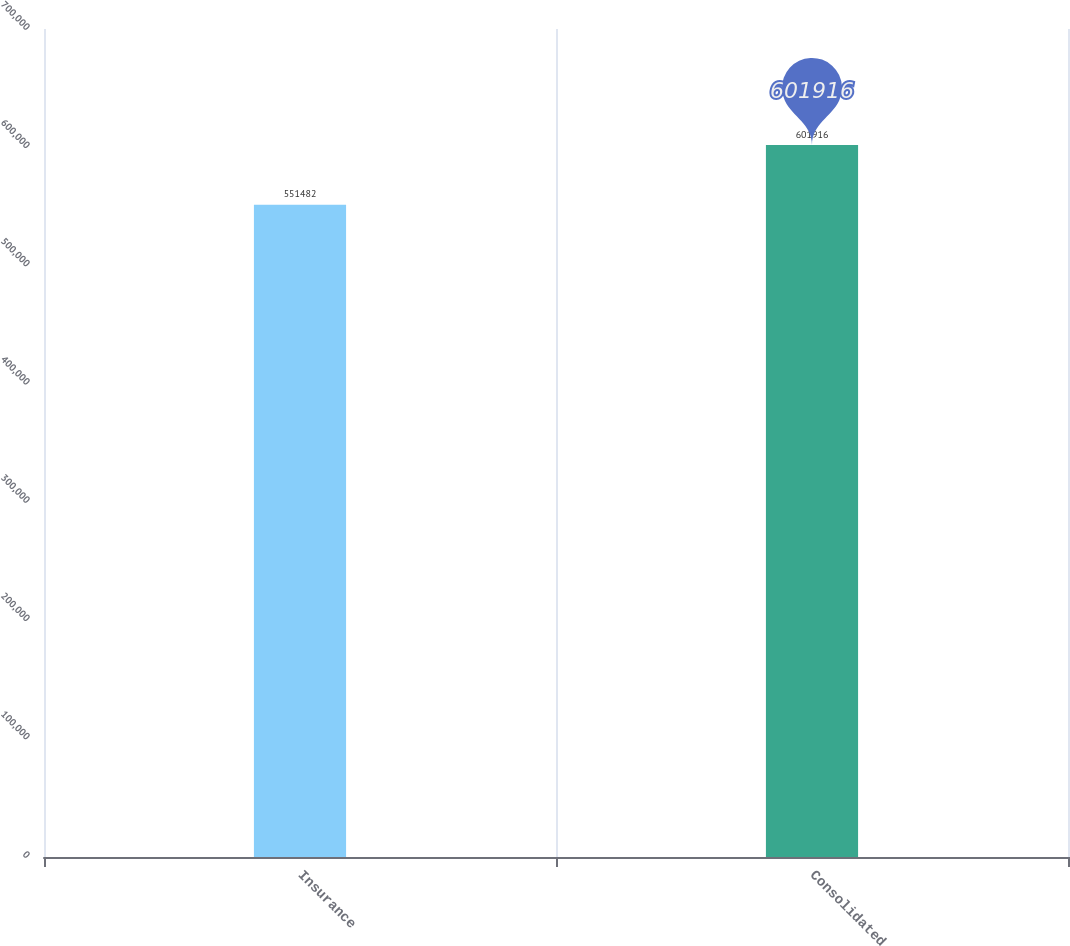Convert chart. <chart><loc_0><loc_0><loc_500><loc_500><bar_chart><fcel>Insurance<fcel>Consolidated<nl><fcel>551482<fcel>601916<nl></chart> 